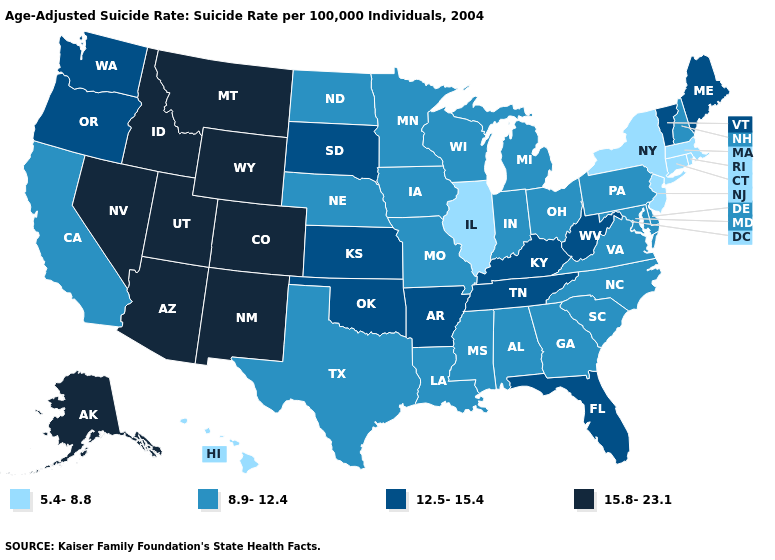What is the value of South Dakota?
Answer briefly. 12.5-15.4. Name the states that have a value in the range 15.8-23.1?
Write a very short answer. Alaska, Arizona, Colorado, Idaho, Montana, Nevada, New Mexico, Utah, Wyoming. What is the value of Florida?
Keep it brief. 12.5-15.4. Name the states that have a value in the range 5.4-8.8?
Write a very short answer. Connecticut, Hawaii, Illinois, Massachusetts, New Jersey, New York, Rhode Island. What is the value of Hawaii?
Concise answer only. 5.4-8.8. Does the map have missing data?
Quick response, please. No. Does New Jersey have the lowest value in the USA?
Concise answer only. Yes. Among the states that border West Virginia , does Kentucky have the lowest value?
Short answer required. No. Which states have the lowest value in the South?
Concise answer only. Alabama, Delaware, Georgia, Louisiana, Maryland, Mississippi, North Carolina, South Carolina, Texas, Virginia. Among the states that border Georgia , does Florida have the highest value?
Write a very short answer. Yes. Name the states that have a value in the range 5.4-8.8?
Be succinct. Connecticut, Hawaii, Illinois, Massachusetts, New Jersey, New York, Rhode Island. What is the lowest value in the USA?
Keep it brief. 5.4-8.8. What is the lowest value in the USA?
Write a very short answer. 5.4-8.8. Is the legend a continuous bar?
Concise answer only. No. What is the value of South Dakota?
Give a very brief answer. 12.5-15.4. 